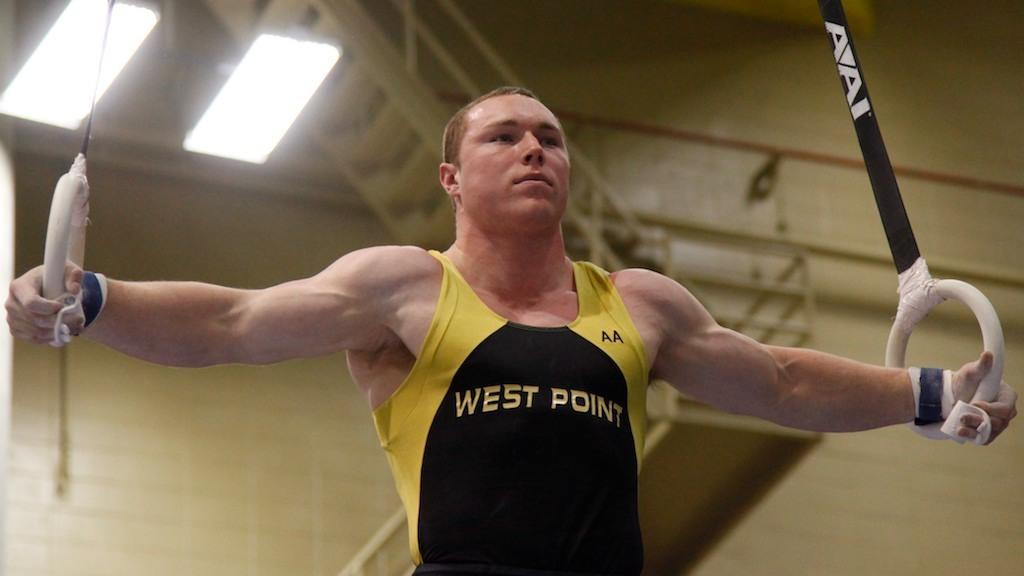<image>
Present a compact description of the photo's key features. a gymnast on the rings from west point 